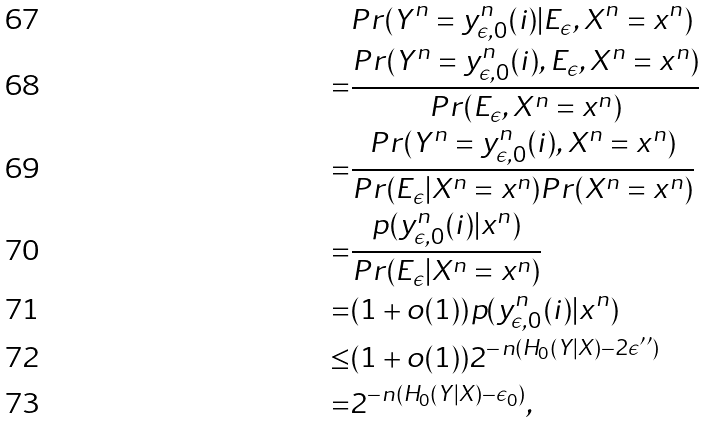<formula> <loc_0><loc_0><loc_500><loc_500>& P r ( Y ^ { n } = y _ { \epsilon , 0 } ^ { n } ( i ) | E _ { \epsilon } , X ^ { n } = x ^ { n } ) \\ = & \frac { P r ( Y ^ { n } = y _ { \epsilon , 0 } ^ { n } ( i ) , E _ { \epsilon } , X ^ { n } = x ^ { n } ) } { P r ( E _ { \epsilon } , X ^ { n } = x ^ { n } ) } \\ = & \frac { P r ( Y ^ { n } = y _ { \epsilon , 0 } ^ { n } ( i ) , X ^ { n } = x ^ { n } ) } { P r ( E _ { \epsilon } | X ^ { n } = x ^ { n } ) P r ( X ^ { n } = x ^ { n } ) } \\ = & \frac { p ( y _ { \epsilon , 0 } ^ { n } ( i ) | x ^ { n } ) } { P r ( E _ { \epsilon } | X ^ { n } = x ^ { n } ) } \\ = & ( 1 + o ( 1 ) ) p ( y _ { \epsilon , 0 } ^ { n } ( i ) | x ^ { n } ) \\ \leq & ( 1 + o ( 1 ) ) 2 ^ { - n ( H _ { 0 } ( Y | X ) - 2 \epsilon ^ { \prime \prime } ) } \\ = & 2 ^ { - n ( H _ { 0 } ( Y | X ) - \epsilon _ { 0 } ) } ,</formula> 